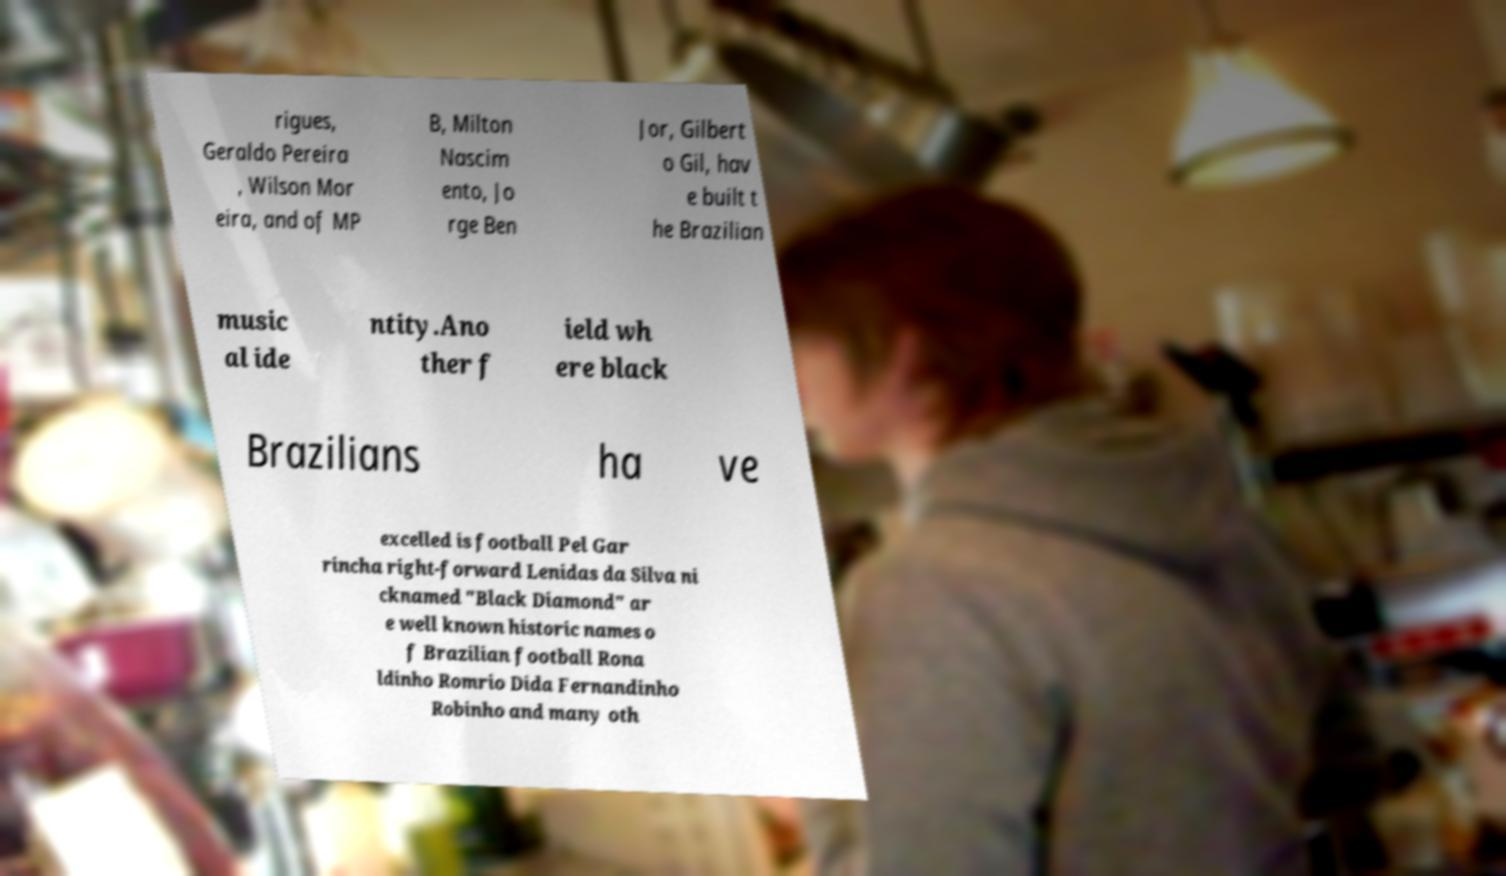Could you extract and type out the text from this image? rigues, Geraldo Pereira , Wilson Mor eira, and of MP B, Milton Nascim ento, Jo rge Ben Jor, Gilbert o Gil, hav e built t he Brazilian music al ide ntity.Ano ther f ield wh ere black Brazilians ha ve excelled is football Pel Gar rincha right-forward Lenidas da Silva ni cknamed "Black Diamond" ar e well known historic names o f Brazilian football Rona ldinho Romrio Dida Fernandinho Robinho and many oth 